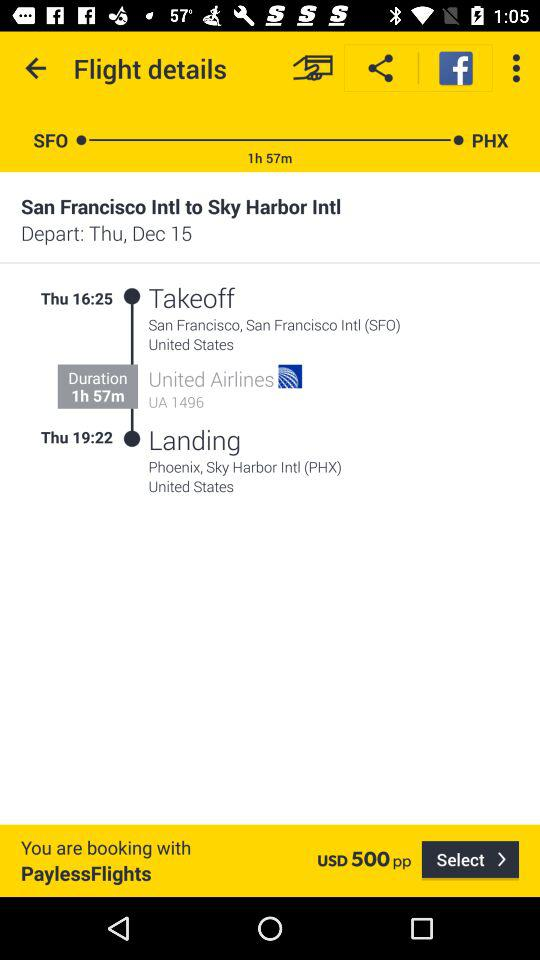What is the departure location? The departure location is San Francisco, San Francisco Intl. (SFO), United States. 